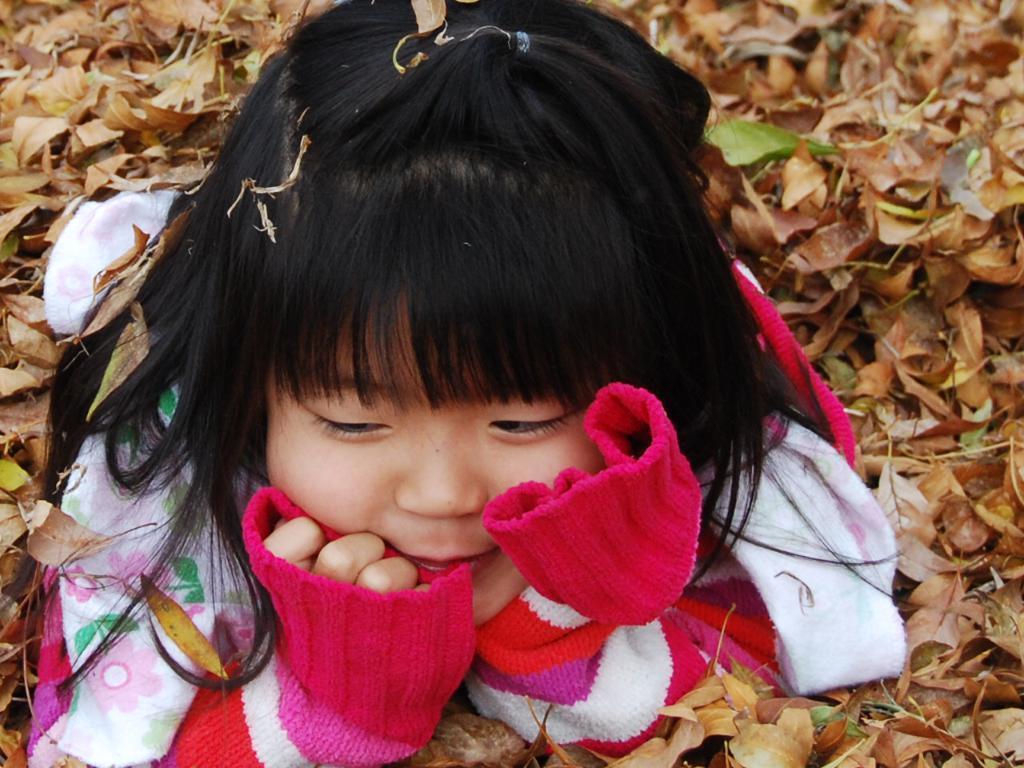In one or two sentences, can you explain what this image depicts? In this image we can see one girl lying on the dried leaves and some dried leaves on the ground. 